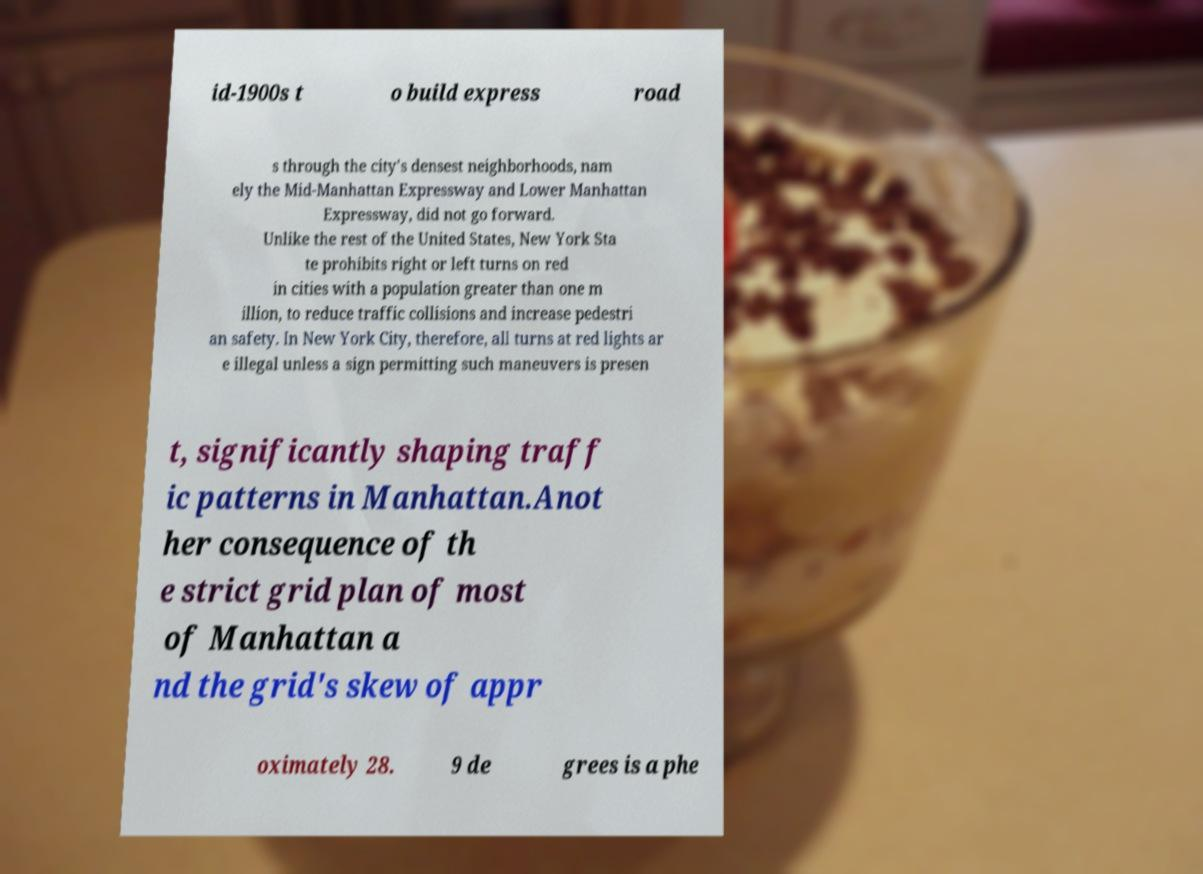What messages or text are displayed in this image? I need them in a readable, typed format. id-1900s t o build express road s through the city's densest neighborhoods, nam ely the Mid-Manhattan Expressway and Lower Manhattan Expressway, did not go forward. Unlike the rest of the United States, New York Sta te prohibits right or left turns on red in cities with a population greater than one m illion, to reduce traffic collisions and increase pedestri an safety. In New York City, therefore, all turns at red lights ar e illegal unless a sign permitting such maneuvers is presen t, significantly shaping traff ic patterns in Manhattan.Anot her consequence of th e strict grid plan of most of Manhattan a nd the grid's skew of appr oximately 28. 9 de grees is a phe 